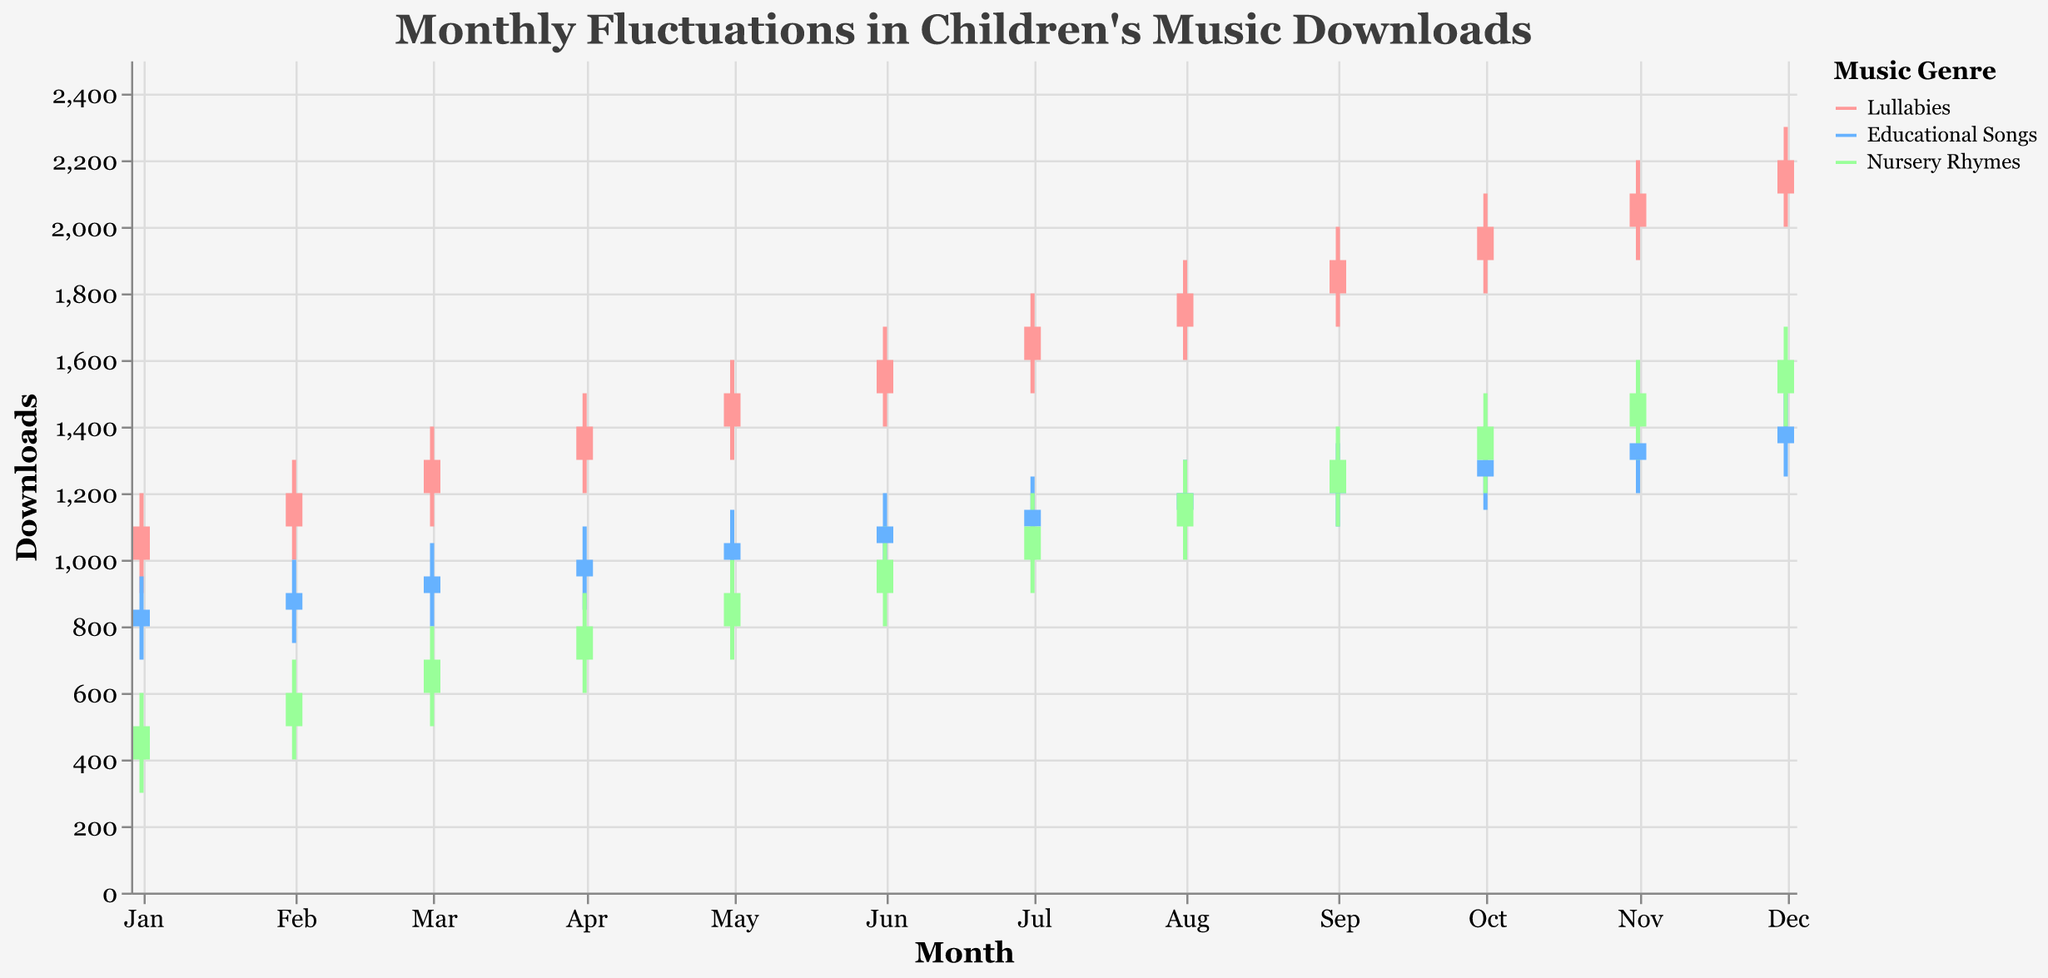What is the title of the figure? The title is displayed at the top of the figure in a font size of 20 and in the color #3D3D3D. It reads: "Monthly Fluctuations in Children's Music Downloads".
Answer: Monthly Fluctuations in Children's Music Downloads What are the three music genres shown in the figure? There are three different colors representing the music genres, labeled in the legend. The genres are Lullabies, Educational Songs, and Nursery Rhymes.
Answer: Lullabies, Educational Songs, Nursery Rhymes In which month did Lullabies have the highest 'Close' value? By looking at the 'Close' values for each month for Lullabies, the month with the highest 'Close' value is December 2023, where the 'Close' value is 2200.
Answer: December 2023 What is the difference between the highest 'High' value and the lowest 'Low' value for Educational Songs in February 2023? For February 2023, the 'High' value for Educational Songs is 1000 and the 'Low' value is 750. The difference is calculated as 1000 - 750 = 250.
Answer: 250 Which genre showed a 'High' value of 1700 in both June and December 2023? By comparing the 'High' values for each genre in June and December 2023, both data points of 1700 can be found in the 'High' values for Nursery Rhymes.
Answer: Nursery Rhymes Did the downloads for Nursery Rhymes ever fall below 500 in any month during 2023? Checking the 'Low' values for Nursery Rhymes for each month, the lowest value is 300 in January 2023, which is below 500.
Answer: Yes What is the trend of the 'Close' values for Lullabies from January to December 2023? Observing the 'Close' values for Lullabies from January to December 2023 shows an increasing trend. The 'Close' value starts at 1100 in January and ends at 2200 in December, consistently rising each month.
Answer: Increasing Which genre has the smallest range between its 'High' and 'Low' values in November 2023? In November 2023, calculating the range (High - Low) for each genre gives: 
- Lullabies: 2200 - 1900 = 300
- Educational Songs: 1450 - 1200 = 250
- Nursery Rhymes: 1600 - 1300 = 300
Educational Songs has the smallest range.
Answer: Educational Songs 